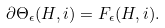Convert formula to latex. <formula><loc_0><loc_0><loc_500><loc_500>\partial \Theta _ { \epsilon } ( H , i ) = F _ { \epsilon } ( H , i ) .</formula> 